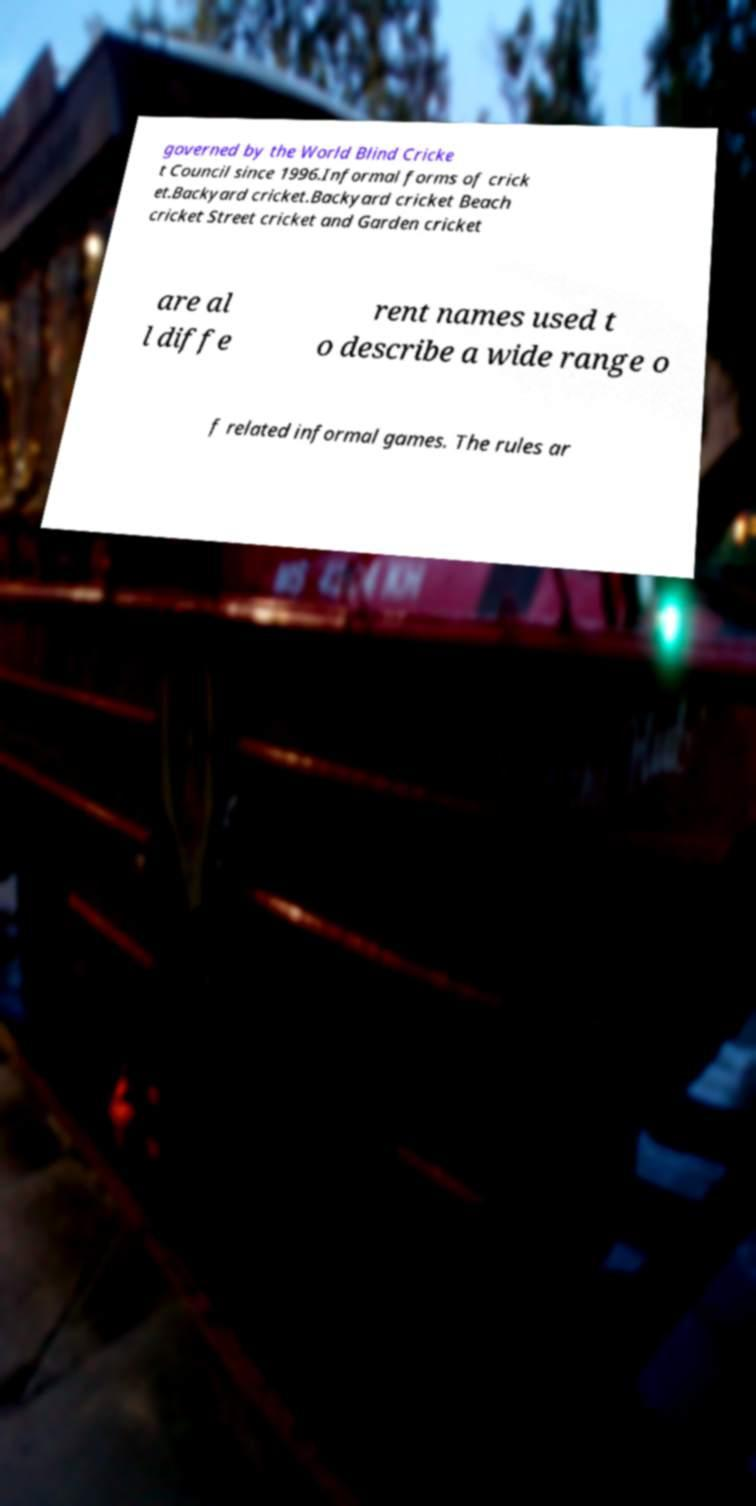Please identify and transcribe the text found in this image. governed by the World Blind Cricke t Council since 1996.Informal forms of crick et.Backyard cricket.Backyard cricket Beach cricket Street cricket and Garden cricket are al l diffe rent names used t o describe a wide range o f related informal games. The rules ar 